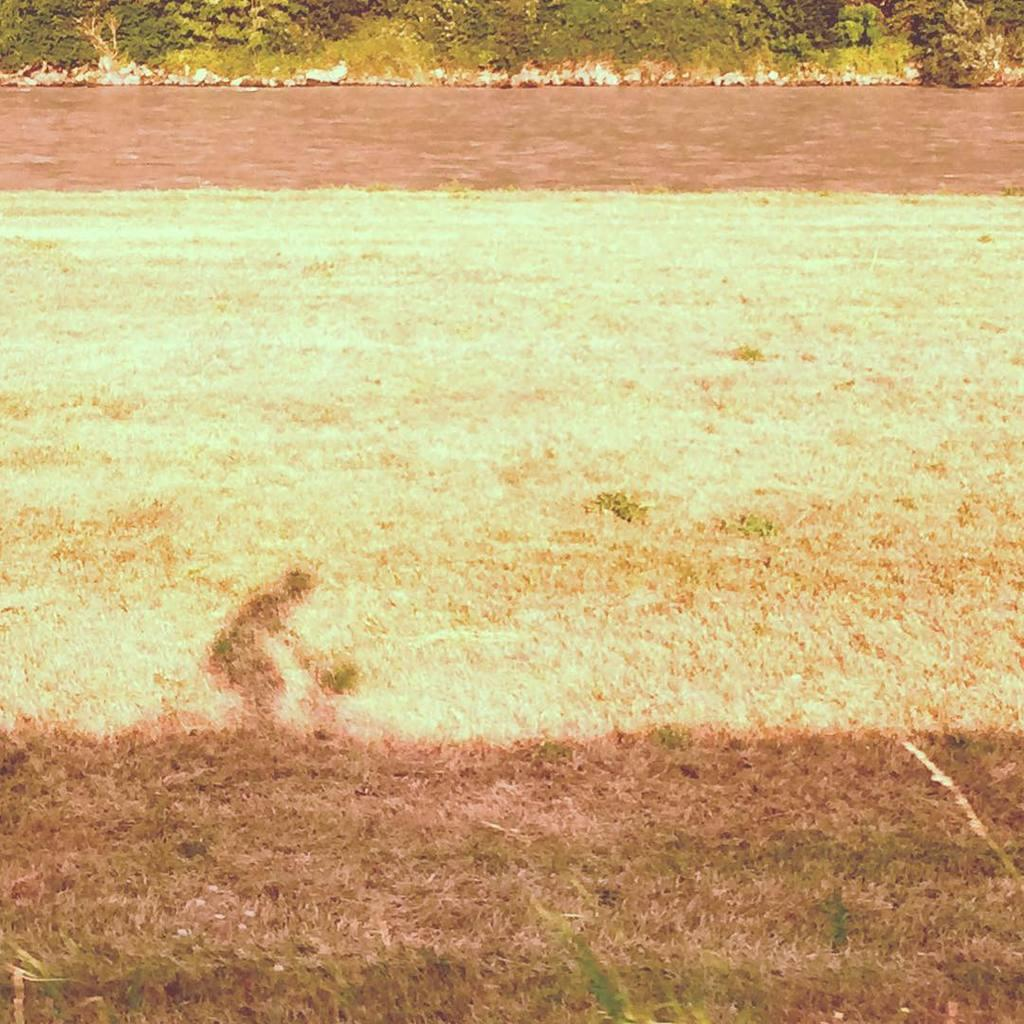What type of surface is visible in the image? There is ground in the image. What covers the ground in the image? There is grass on the ground. What other vegetation can be seen on the ground? There are plants on the ground. What else is visible in the image besides the ground and vegetation? There is water visible in the image. Can you describe any other feature in the image? There is a shadow in the image. What type of vessel is being carried by the person sitting on the throne in the image? There is no person sitting on a throne or carrying a vessel in the image. 